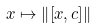<formula> <loc_0><loc_0><loc_500><loc_500>x \mapsto \left \| \left [ x , c \right ] \right \|</formula> 